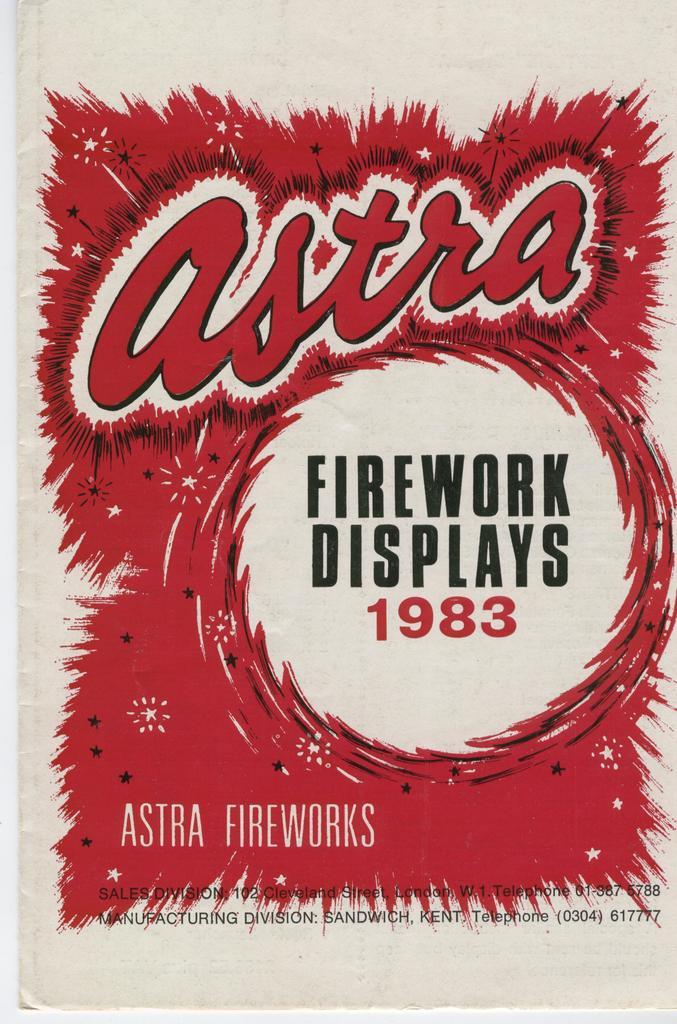What year were the fireworks?
Provide a short and direct response. 1983. What is the name of the firework displays?
Offer a terse response. Astra. 